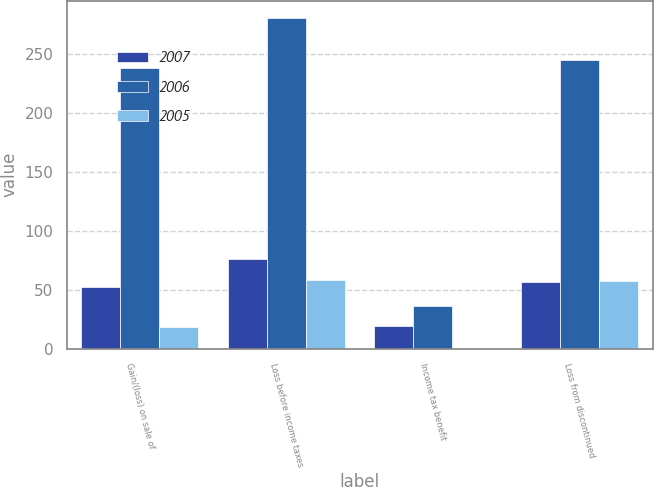Convert chart. <chart><loc_0><loc_0><loc_500><loc_500><stacked_bar_chart><ecel><fcel>Gain/(loss) on sale of<fcel>Loss before income taxes<fcel>Income tax benefit<fcel>Loss from discontinued<nl><fcel>2007<fcel>52.5<fcel>75.8<fcel>19.4<fcel>56.4<nl><fcel>2006<fcel>237.4<fcel>280.6<fcel>36<fcel>244.6<nl><fcel>2005<fcel>18.7<fcel>58.4<fcel>0.8<fcel>57.6<nl></chart> 